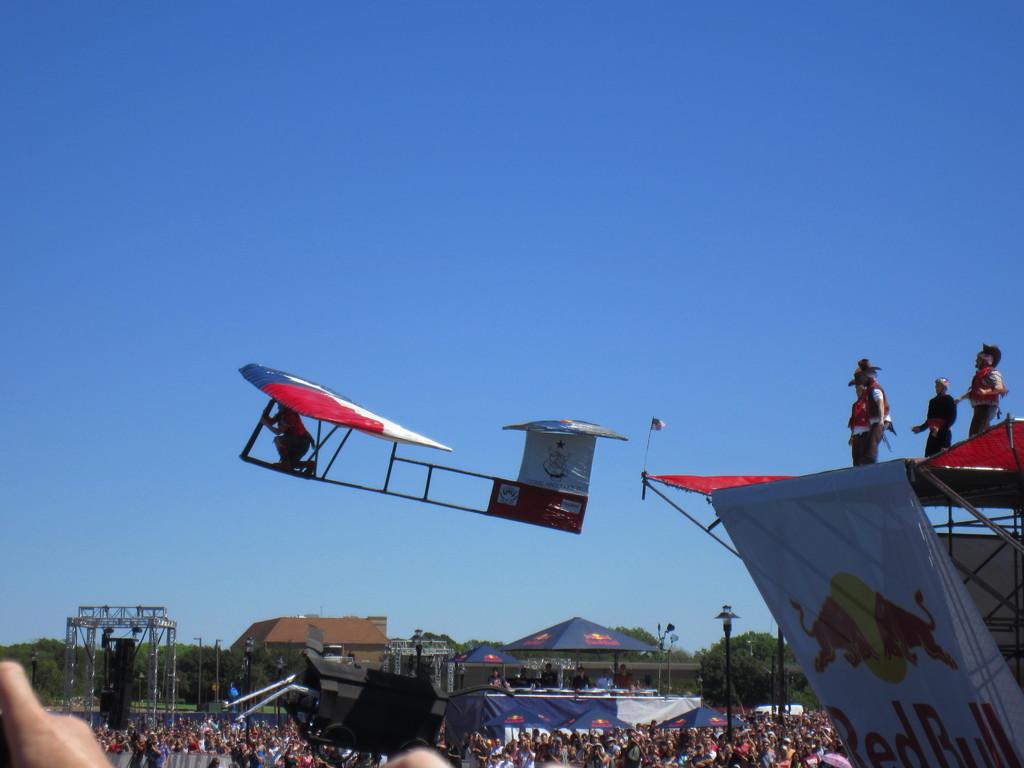Who sponsers this?
Your answer should be very brief. Red bull. 